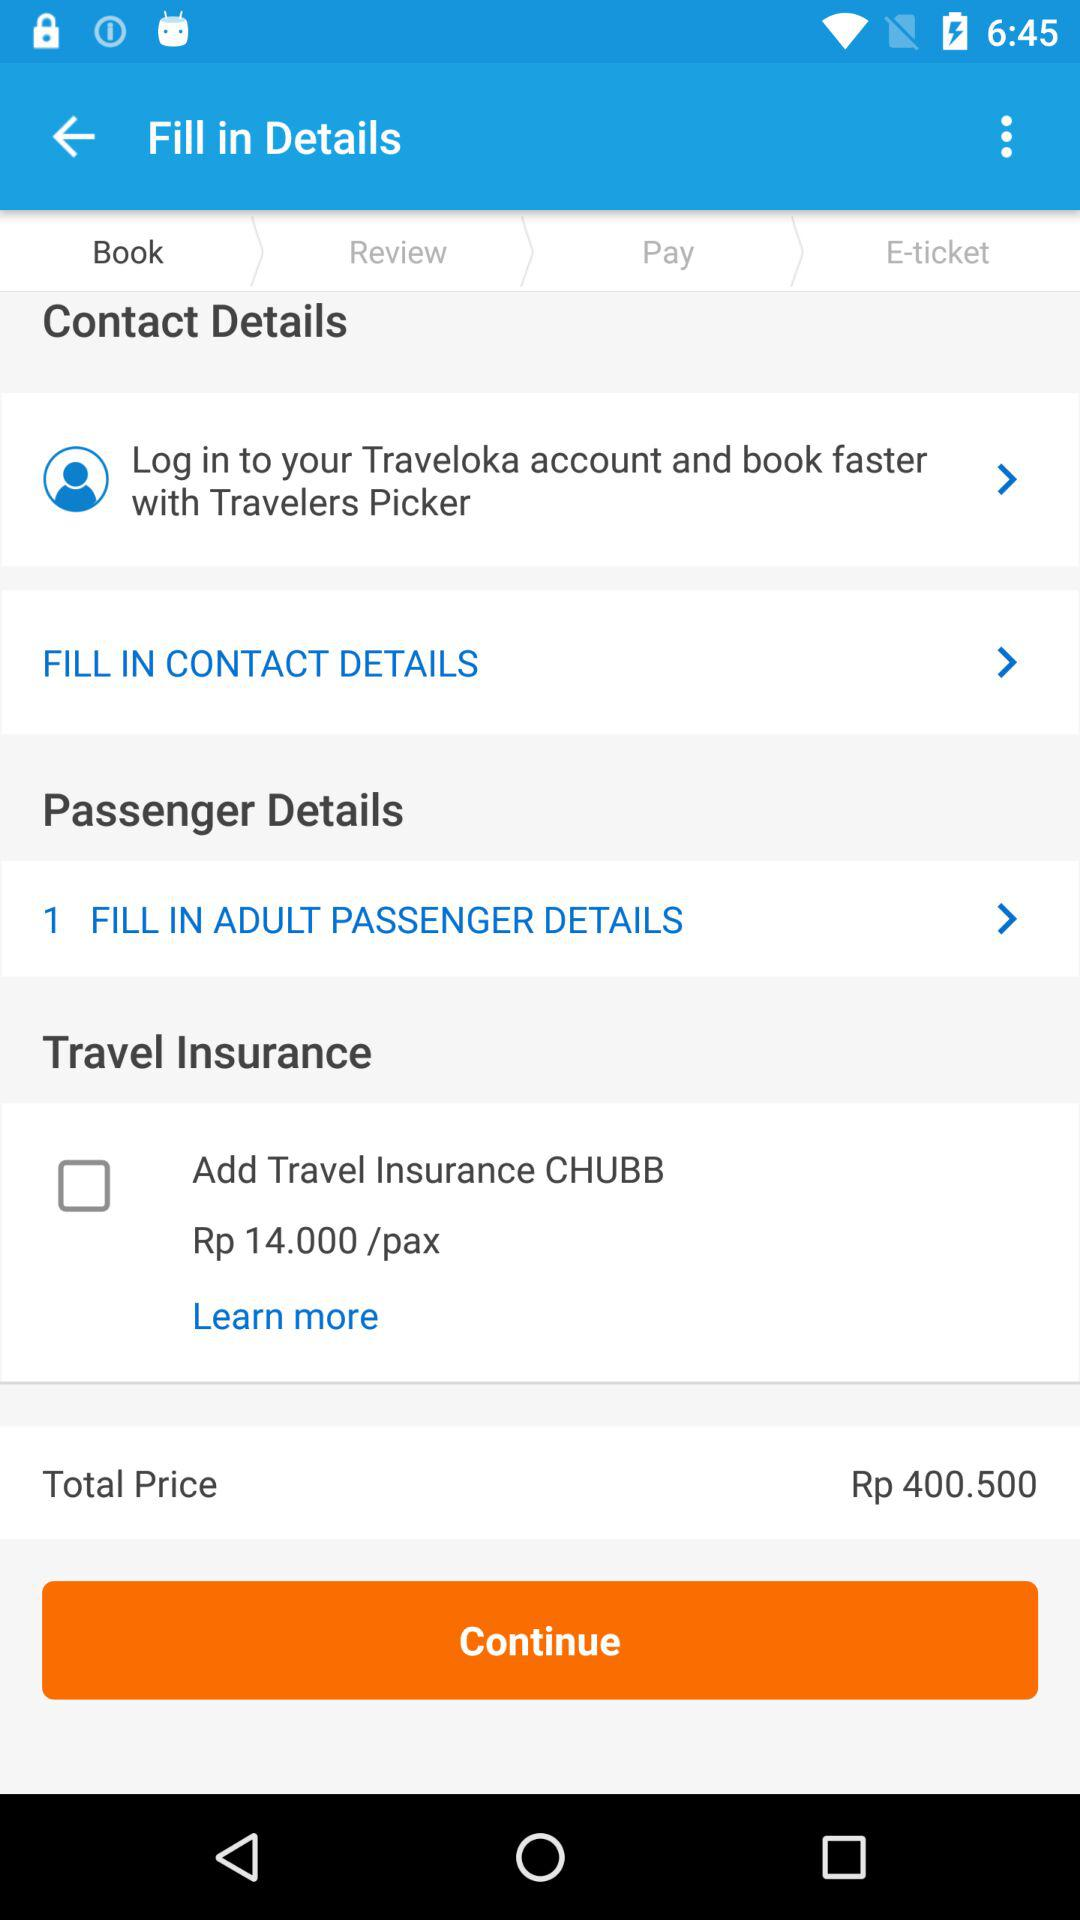What does the process 'Fill in Adult Passenger Details' involve? Filling in the adult passenger details typically requires you to provide information such as full name, identification number, and contact details. These are necessary for the booking and check-in processes. Is it possible to book for multiple passengers at once? Yes, you can book tickets for multiple passengers. Just ensure you provide accurate details for each passenger as required in the 'Fill in Adult Passenger Details' section. 